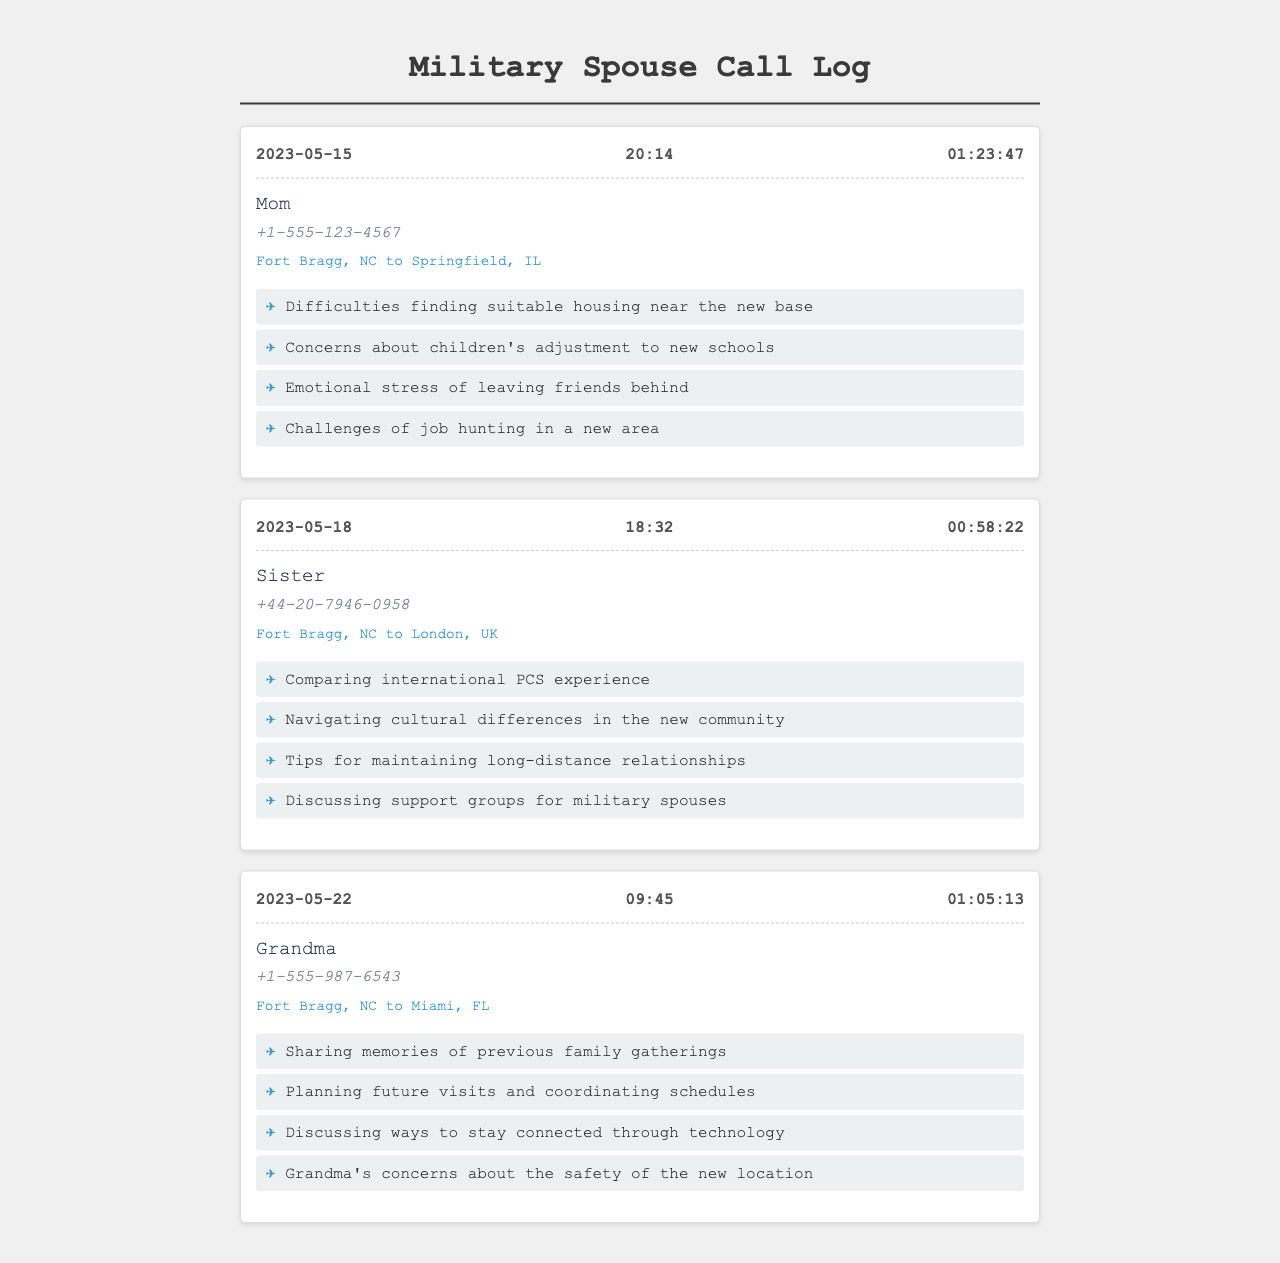What is the date of the longest call? The longest call is on May 15, 2023, with a duration of 01:23:47.
Answer: 2023-05-15 Who did the spouse call on May 18, 2023? The spouse called their sister on this date.
Answer: Sister How long was the call with Grandma? The duration of the call with Grandma was 01:05:13.
Answer: 01:05:13 What were the concerns discussed during the call with Mom? The topics included housing difficulties, children's adjustment, emotional stress, and job hunting.
Answer: Housing difficulties Which family member was called from Fort Bragg, NC to London, UK? The call was made to the sister from Fort Bragg, NC to London, UK.
Answer: Sister What technology-related topic was discussed during the call with Grandma? The topic discussed was ways to stay connected through technology.
Answer: Staying connected through technology What was a concern expressed during the call with Grandma? Grandma expressed concerns about the safety of the new location.
Answer: Safety of the new location How many international calls are recorded in the log? There are three international calls recorded in the log.
Answer: Three 